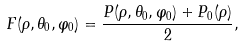Convert formula to latex. <formula><loc_0><loc_0><loc_500><loc_500>F ( \rho , \theta _ { 0 } , \varphi _ { 0 } ) = \frac { P ( \rho , \theta _ { 0 } , \varphi _ { 0 } ) + P _ { 0 } ( \rho ) } { 2 } ,</formula> 